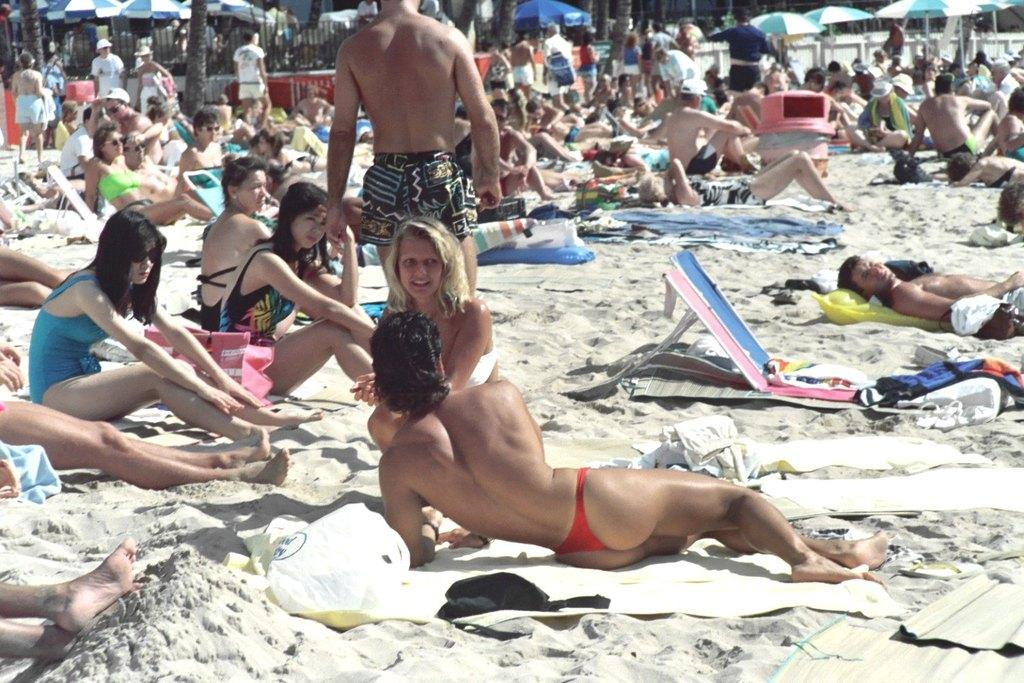What are the people in the image doing? In the image, there are people seated, laying on the ground, standing, and walking. What might be used to provide shade in the image? Umbrellas are visible in the image, which could be used to provide shade. What type of natural vegetation is present in the image? Trees are present in the image. What word is written on the car in the image? There is no car present in the image, so no word can be observed on a car. How many drops of water are visible on the people walking in the image? There is no mention of water or drops in the image, so it is not possible to determine the number of drops on the people walking. 